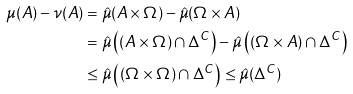<formula> <loc_0><loc_0><loc_500><loc_500>\mu ( A ) - \nu ( A ) & = \hat { \mu } ( A \times \Omega ) - \hat { \mu } ( \Omega \times A ) \\ & = \hat { \mu } \left ( ( A \times \Omega ) \cap \Delta ^ { C } \right ) - \hat { \mu } \left ( ( \Omega \times A ) \cap \Delta ^ { C } \right ) \\ & \leq \hat { \mu } \left ( ( \Omega \times \Omega ) \cap \Delta ^ { C } \right ) \leq \hat { \mu } ( \Delta ^ { C } )</formula> 